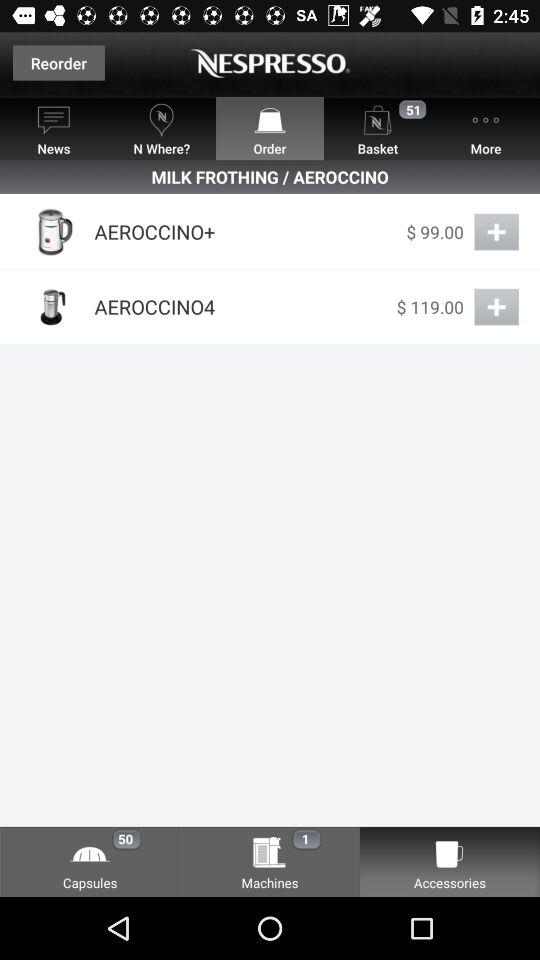How many items are in the basket? There are 51 items in the basket. 